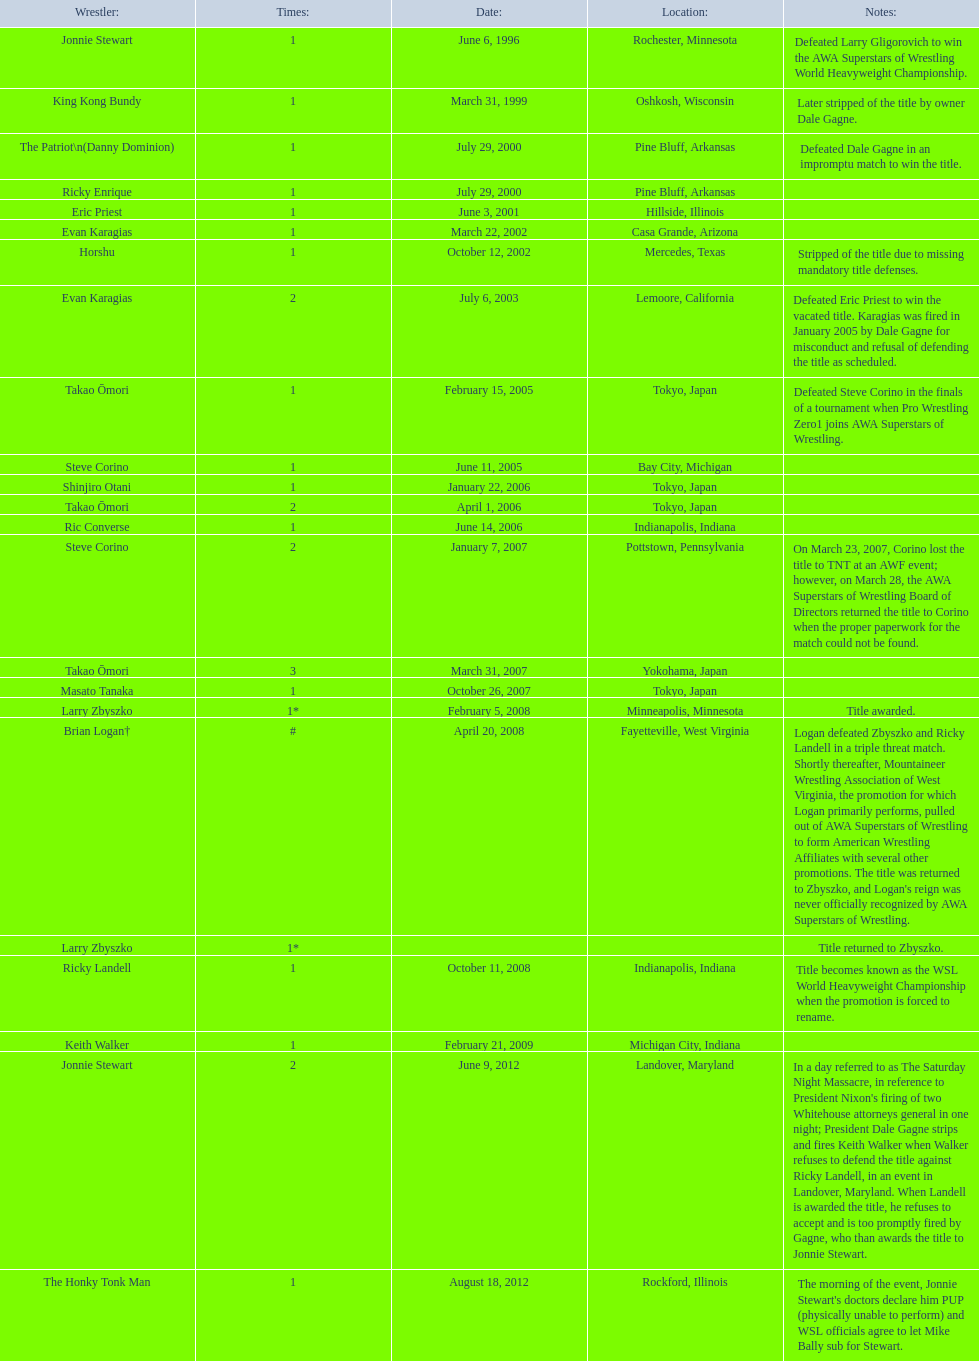Where do the title possessors originate? Rochester, Minnesota, Oshkosh, Wisconsin, Pine Bluff, Arkansas, Pine Bluff, Arkansas, Hillside, Illinois, Casa Grande, Arizona, Mercedes, Texas, Lemoore, California, Tokyo, Japan, Bay City, Michigan, Tokyo, Japan, Tokyo, Japan, Indianapolis, Indiana, Pottstown, Pennsylvania, Yokohama, Japan, Tokyo, Japan, Minneapolis, Minnesota, Fayetteville, West Virginia, , Indianapolis, Indiana, Michigan City, Indiana, Landover, Maryland, Rockford, Illinois. Who is the title possessor from texas? Horshu. 